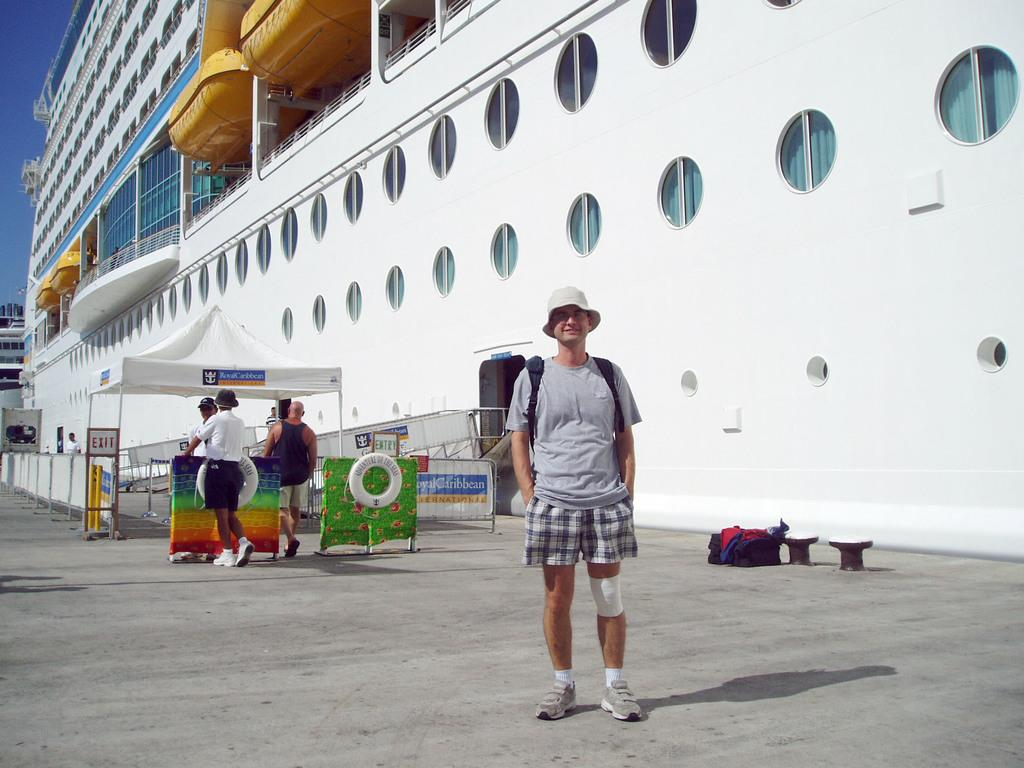What is the main subject in the image? There is a man standing in the image. What can be seen near the man? There are tube lifesavers in the image. How many people are present in the image? There is a group of people standing in the image. What type of structure is visible in the image? There is a stall in the image. What might be used to control the flow of people or vehicles in the image? There are barriers in the image. What is the background of the image? The sky is visible in the background of the image. What type of furniture can be seen in the image? There is no furniture present in the image. How does the ship surprise the people in the image? The image does not depict any surprises or reactions to the ship; it simply shows the ship in the background. 